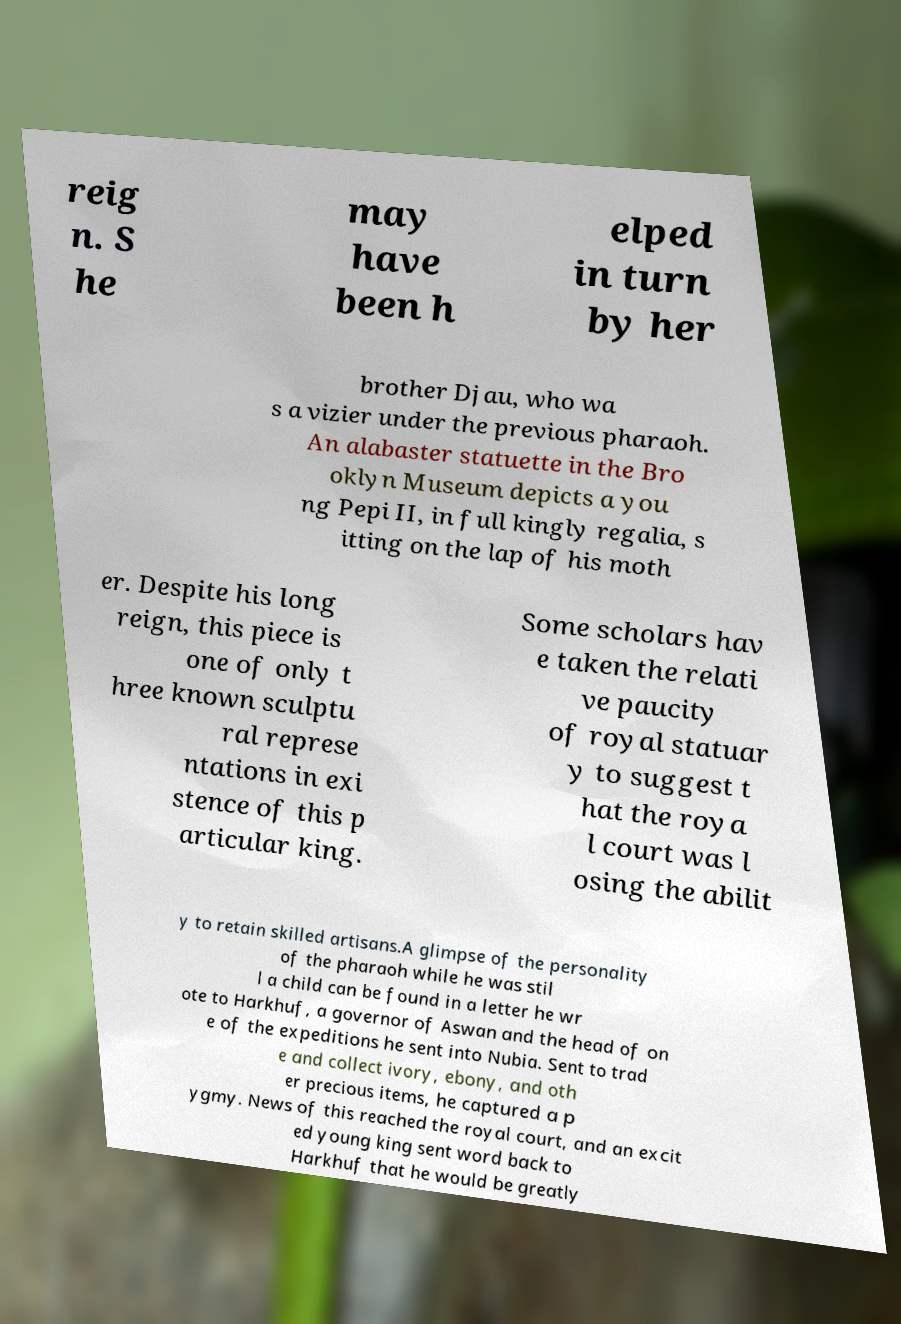Could you extract and type out the text from this image? reig n. S he may have been h elped in turn by her brother Djau, who wa s a vizier under the previous pharaoh. An alabaster statuette in the Bro oklyn Museum depicts a you ng Pepi II, in full kingly regalia, s itting on the lap of his moth er. Despite his long reign, this piece is one of only t hree known sculptu ral represe ntations in exi stence of this p articular king. Some scholars hav e taken the relati ve paucity of royal statuar y to suggest t hat the roya l court was l osing the abilit y to retain skilled artisans.A glimpse of the personality of the pharaoh while he was stil l a child can be found in a letter he wr ote to Harkhuf, a governor of Aswan and the head of on e of the expeditions he sent into Nubia. Sent to trad e and collect ivory, ebony, and oth er precious items, he captured a p ygmy. News of this reached the royal court, and an excit ed young king sent word back to Harkhuf that he would be greatly 